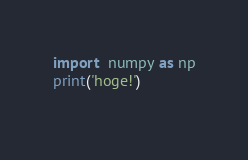<code> <loc_0><loc_0><loc_500><loc_500><_Python_>
import  numpy as np
print('hoge!')
  </code> 